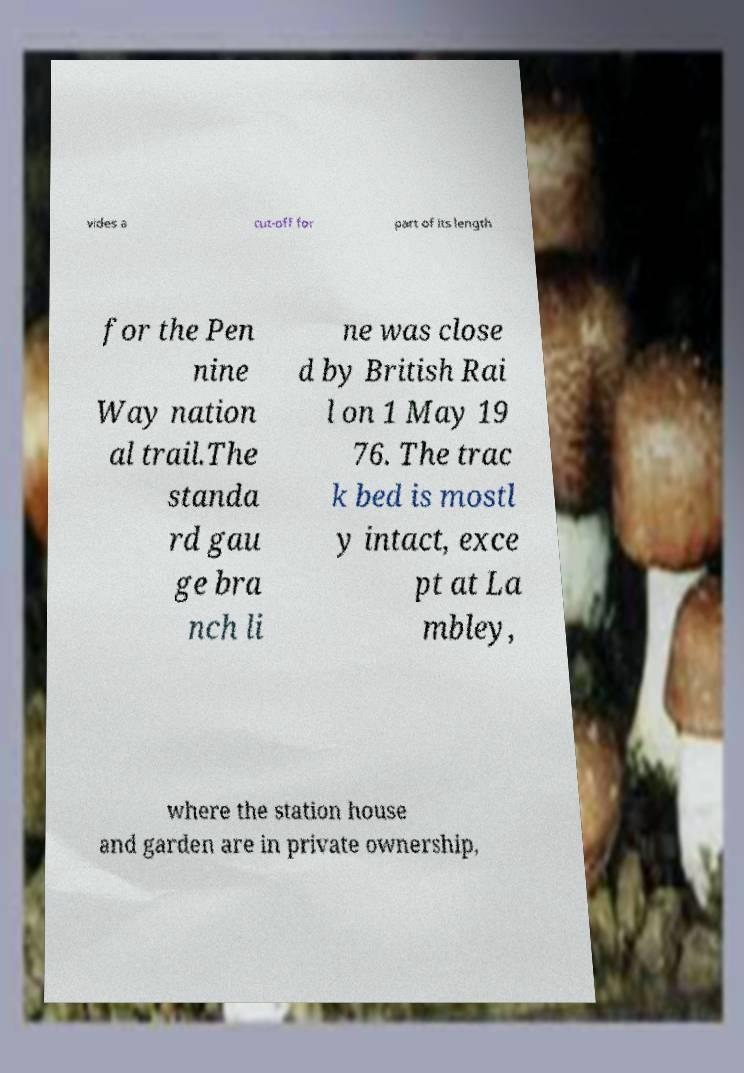What messages or text are displayed in this image? I need them in a readable, typed format. vides a cut-off for part of its length for the Pen nine Way nation al trail.The standa rd gau ge bra nch li ne was close d by British Rai l on 1 May 19 76. The trac k bed is mostl y intact, exce pt at La mbley, where the station house and garden are in private ownership, 